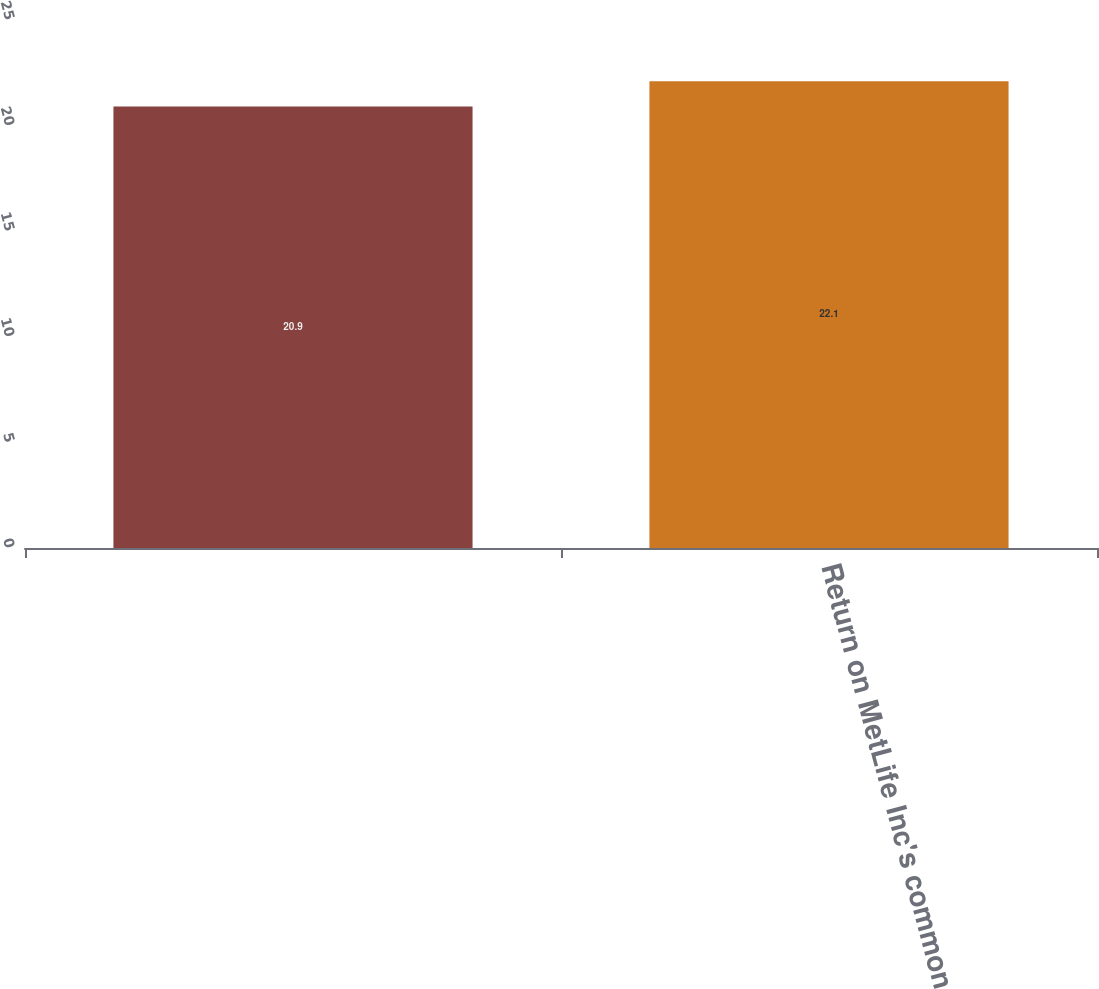Convert chart to OTSL. <chart><loc_0><loc_0><loc_500><loc_500><bar_chart><ecel><fcel>Return on MetLife Inc's common<nl><fcel>20.9<fcel>22.1<nl></chart> 